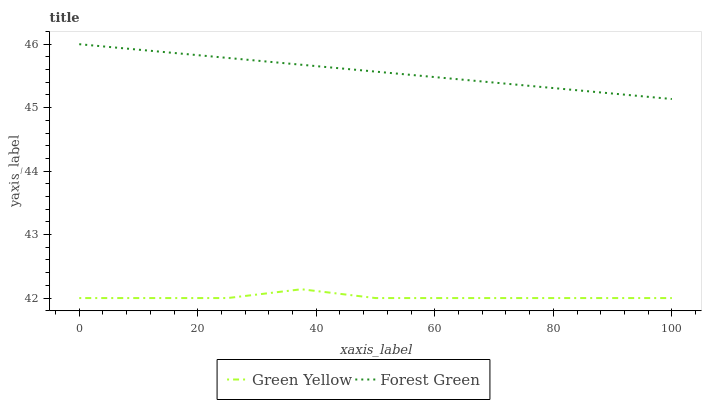Does Green Yellow have the minimum area under the curve?
Answer yes or no. Yes. Does Forest Green have the maximum area under the curve?
Answer yes or no. Yes. Does Green Yellow have the maximum area under the curve?
Answer yes or no. No. Is Forest Green the smoothest?
Answer yes or no. Yes. Is Green Yellow the roughest?
Answer yes or no. Yes. Is Green Yellow the smoothest?
Answer yes or no. No. Does Green Yellow have the lowest value?
Answer yes or no. Yes. Does Forest Green have the highest value?
Answer yes or no. Yes. Does Green Yellow have the highest value?
Answer yes or no. No. Is Green Yellow less than Forest Green?
Answer yes or no. Yes. Is Forest Green greater than Green Yellow?
Answer yes or no. Yes. Does Green Yellow intersect Forest Green?
Answer yes or no. No. 